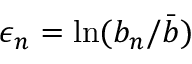Convert formula to latex. <formula><loc_0><loc_0><loc_500><loc_500>\epsilon _ { n } = \ln ( b _ { n } / \bar { b } )</formula> 